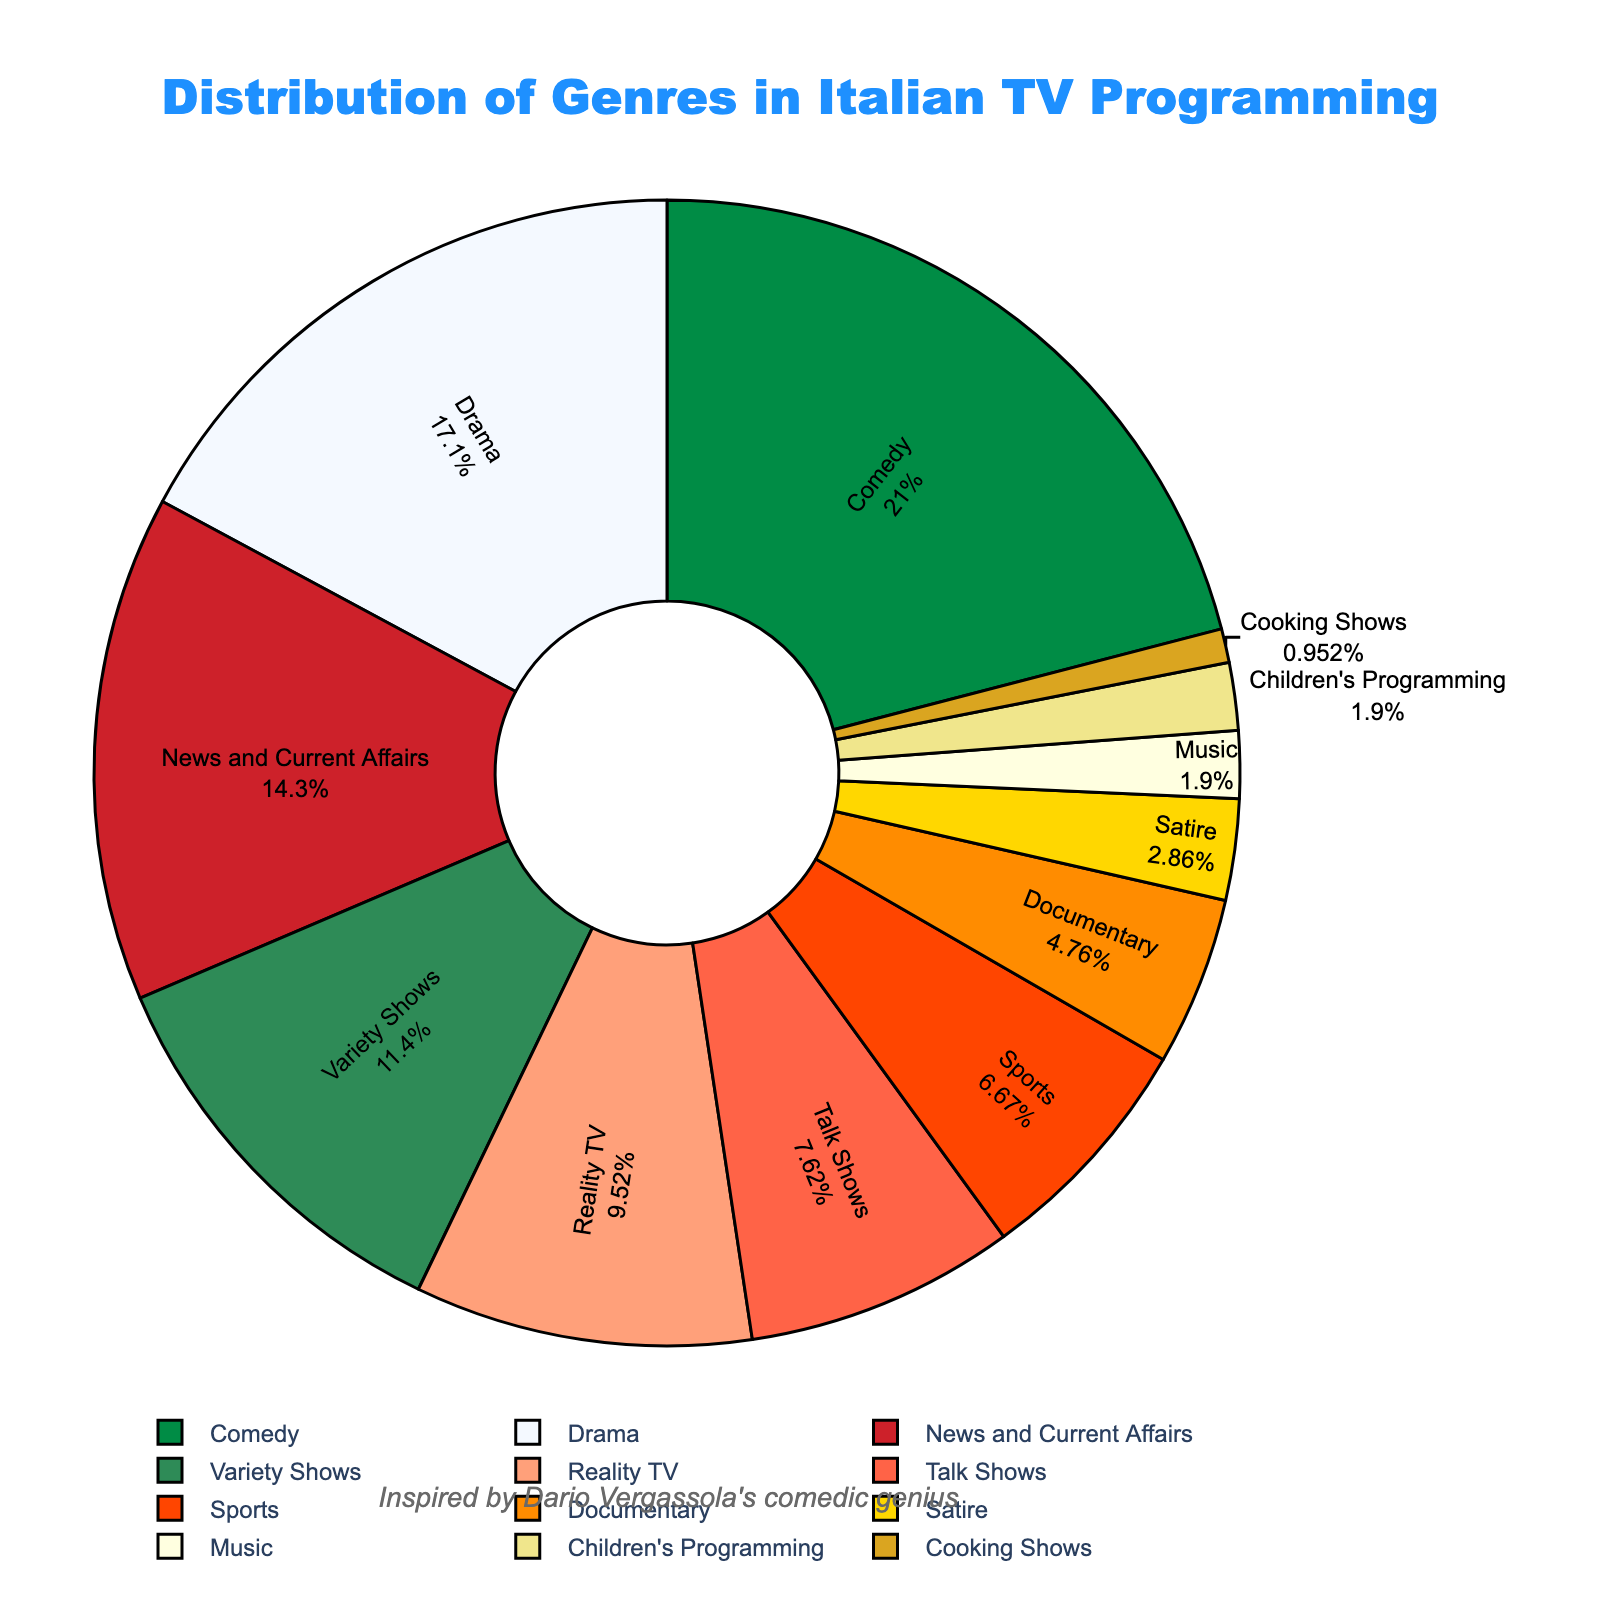What's the most common genre in Italian TV programming? The largest segment of the pie chart represents Comedy, labeled with 22%, indicating it is the most common genre.
Answer: Comedy Which genre is less common, Talk Shows or Reality TV? By observing the size of the pie chart segments and the provided percentages, Talk Shows have 8% while Reality TV has 10%. Therefore, Talk Shows are less common.
Answer: Talk Shows How much more prevalent is Comedy compared to Satire? Comedy accounts for 22% of the programming, while Satire accounts for 3%. The difference is 22 - 3 = 19%.
Answer: 19% What percentage of Italian TV programming is dedicated to non-entertainment genres such as News and Current Affairs, Documentary, and Sports? Summing up News and Current Affairs (15%), Documentary (5%), and Sports (7%) gives 15 + 5 + 7 = 27%.
Answer: 27% Are Cooking Shows or Music programs more represented in the Italian TV programming? The pie chart indicates Cooking Shows account for 1%, while Music is 2%. Therefore, Music programs are more represented.
Answer: Music Between Drama and Variety Shows, which one is more prevalent, and by what percentage? Drama has 18% and Variety Shows have 12%. Drama is more prevalent by 18 - 12 = 6%.
Answer: Drama by 6% What's the combined percentage of the least represented genres (Children's Programming, Music, Cooking Shows)? Adding Children's Programming (2%), Music (2%), and Cooking Shows (1%) gives 2 + 2 + 1 = 5%.
Answer: 5% How much less is the percentage of Talk Shows compared to News and Current Affairs? News and Current Affairs is 15% and Talk Shows is 8%. The difference is 15 - 8 = 7%.
Answer: 7% Which genre, represented by bright green, has a higher percentage than Reality TV? By visual inspection of the colors and checking the genres, Drama (18%) is represented by bright green and has a higher percentage than Reality TV (10%).
Answer: Drama What is the ratio of Comedy to Children's Programming in Italian TV programming? Comedy is 22%, and Children's Programming is 2%. The ratio is 22/2 = 11:1.
Answer: 11:1 